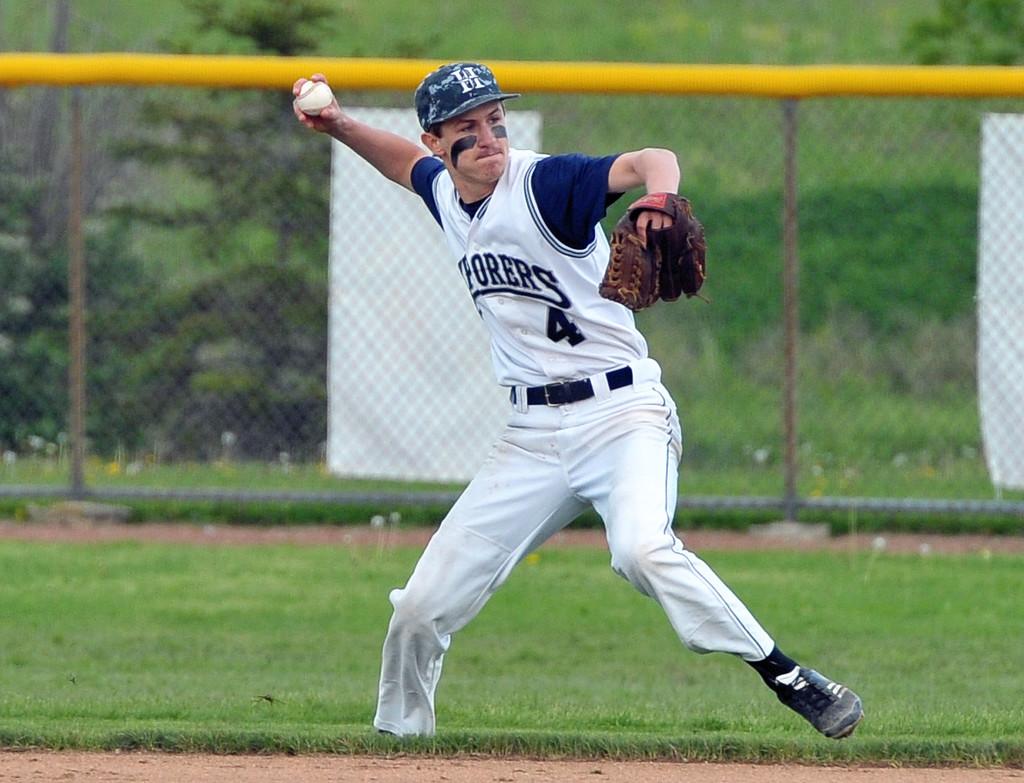What number is this player?
Provide a short and direct response. 4. 